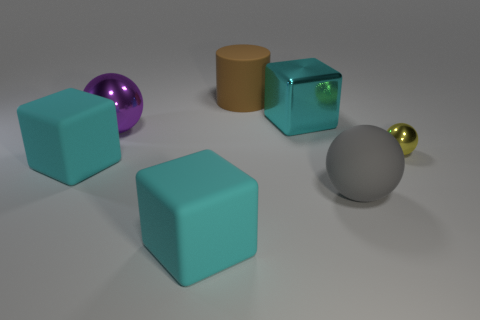Add 2 purple metallic objects. How many objects exist? 9 Subtract all cylinders. How many objects are left? 6 Add 3 balls. How many balls exist? 6 Subtract 0 green spheres. How many objects are left? 7 Subtract all large cyan shiny blocks. Subtract all gray objects. How many objects are left? 5 Add 1 big cyan metallic things. How many big cyan metallic things are left? 2 